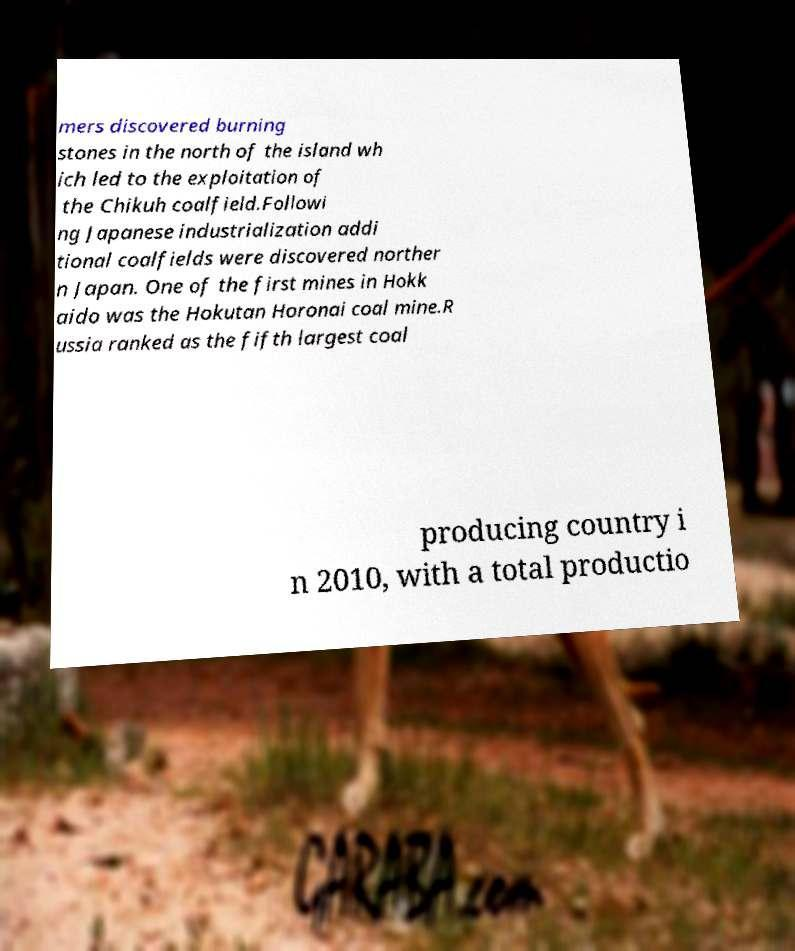Please identify and transcribe the text found in this image. mers discovered burning stones in the north of the island wh ich led to the exploitation of the Chikuh coalfield.Followi ng Japanese industrialization addi tional coalfields were discovered norther n Japan. One of the first mines in Hokk aido was the Hokutan Horonai coal mine.R ussia ranked as the fifth largest coal producing country i n 2010, with a total productio 